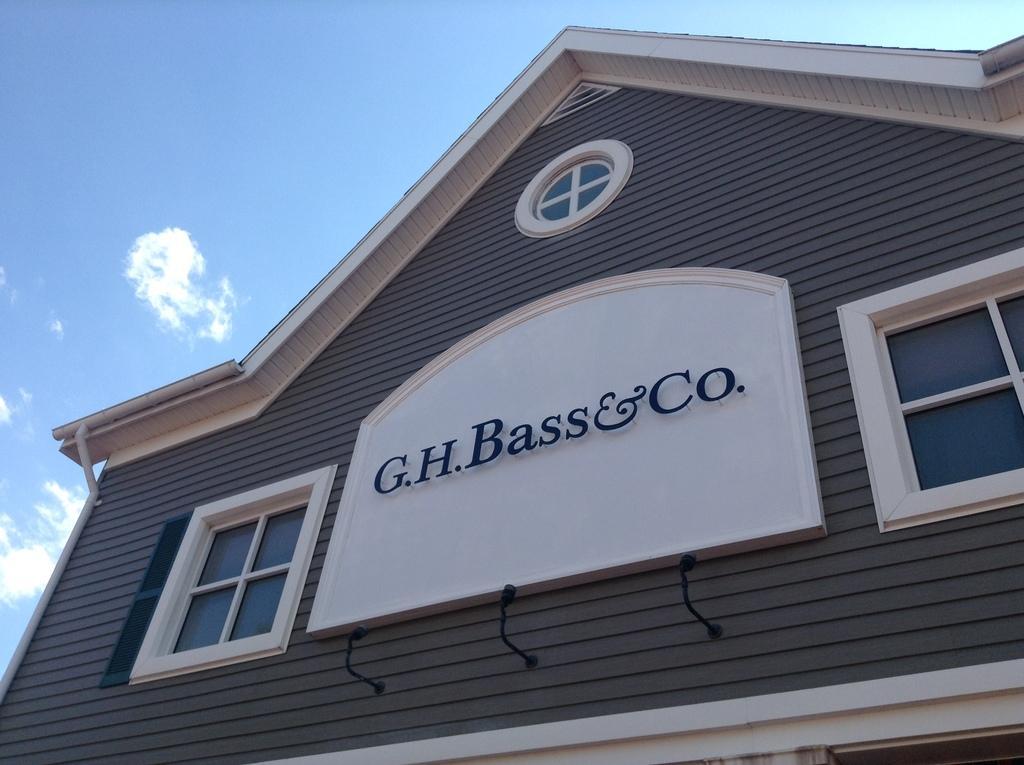Please provide a concise description of this image. In the picture we can see a house on it, we can see two windows with a name on it G. H. Bass and Co and in the background we can see a sky with clouds. 